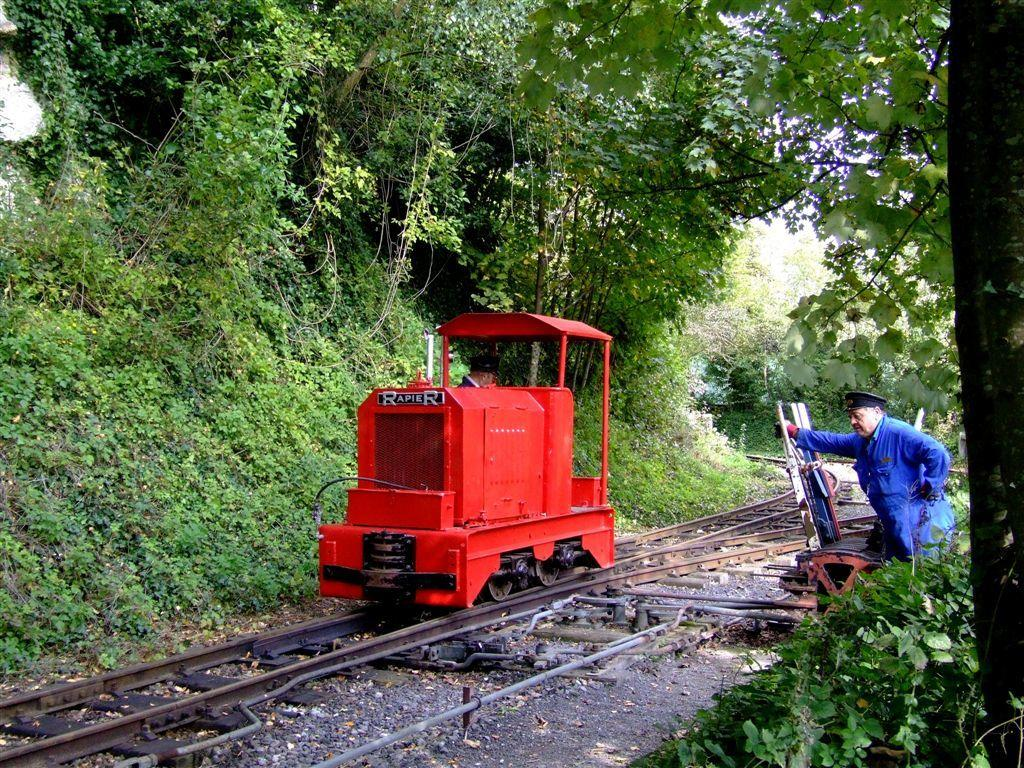What is the main subject in the center of the image? There is a railway speeder on the railway track in the image. Where is the railway speeder located in relation to the image? The railway speeder is in the center of the image. What can be seen on the right side of the image? There is a man standing on the right side of the image. What type of natural environment is visible in the background of the image? There are trees in the background of the image. What type of vegetation is visible in the image? Plants are visible in the image. How many patches of grass are visible on the hill in the image? There is no hill or patches of grass present in the image. 